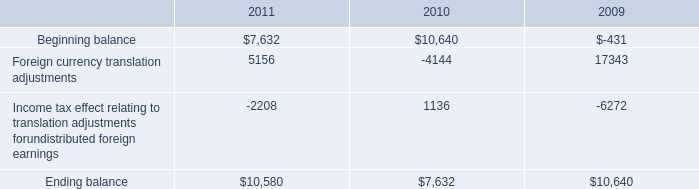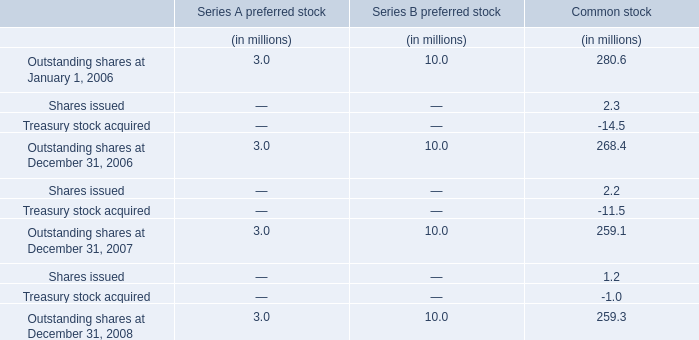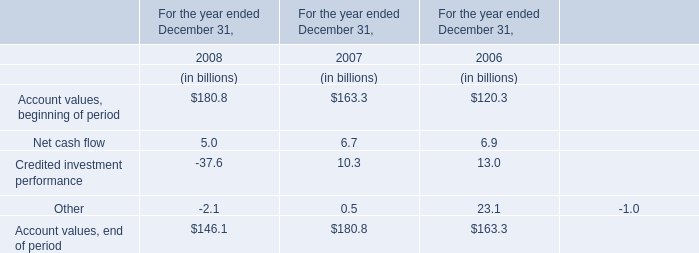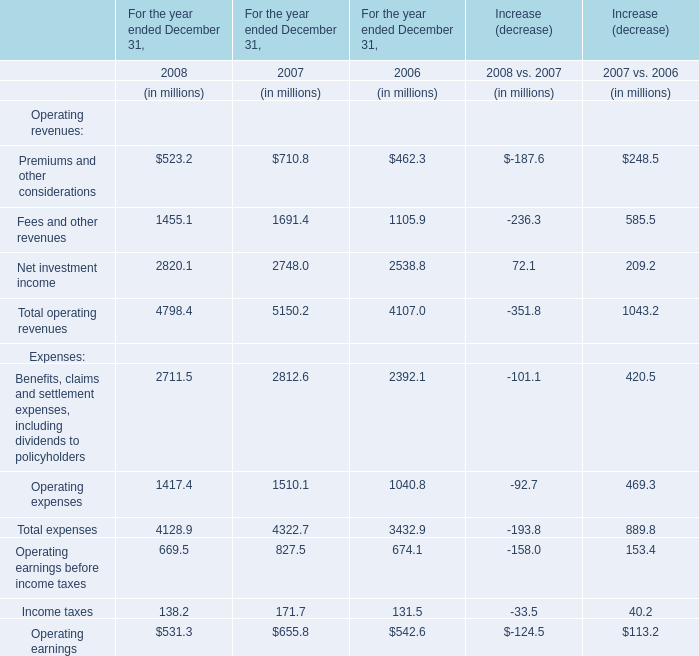What is the average increasing rate of Net investment income between 2007 and 2008? (in %) 
Computations: ((((2820.1 - 2748) / 2748) + ((2748 - 2538.8) / 2538.8)) / 2)
Answer: 0.05432. 